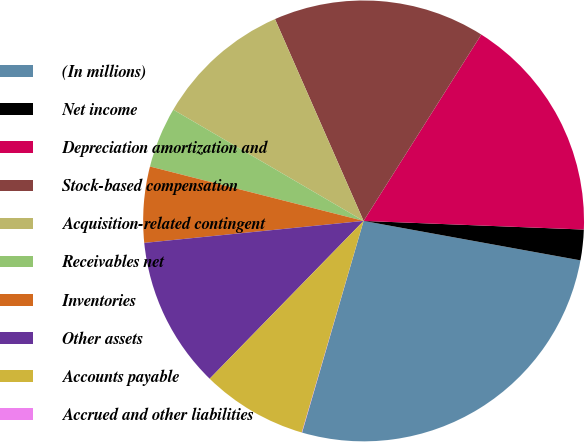Convert chart to OTSL. <chart><loc_0><loc_0><loc_500><loc_500><pie_chart><fcel>(In millions)<fcel>Net income<fcel>Depreciation amortization and<fcel>Stock-based compensation<fcel>Acquisition-related contingent<fcel>Receivables net<fcel>Inventories<fcel>Other assets<fcel>Accounts payable<fcel>Accrued and other liabilities<nl><fcel>26.64%<fcel>2.24%<fcel>16.66%<fcel>15.55%<fcel>10.0%<fcel>4.45%<fcel>5.56%<fcel>11.11%<fcel>7.78%<fcel>0.02%<nl></chart> 